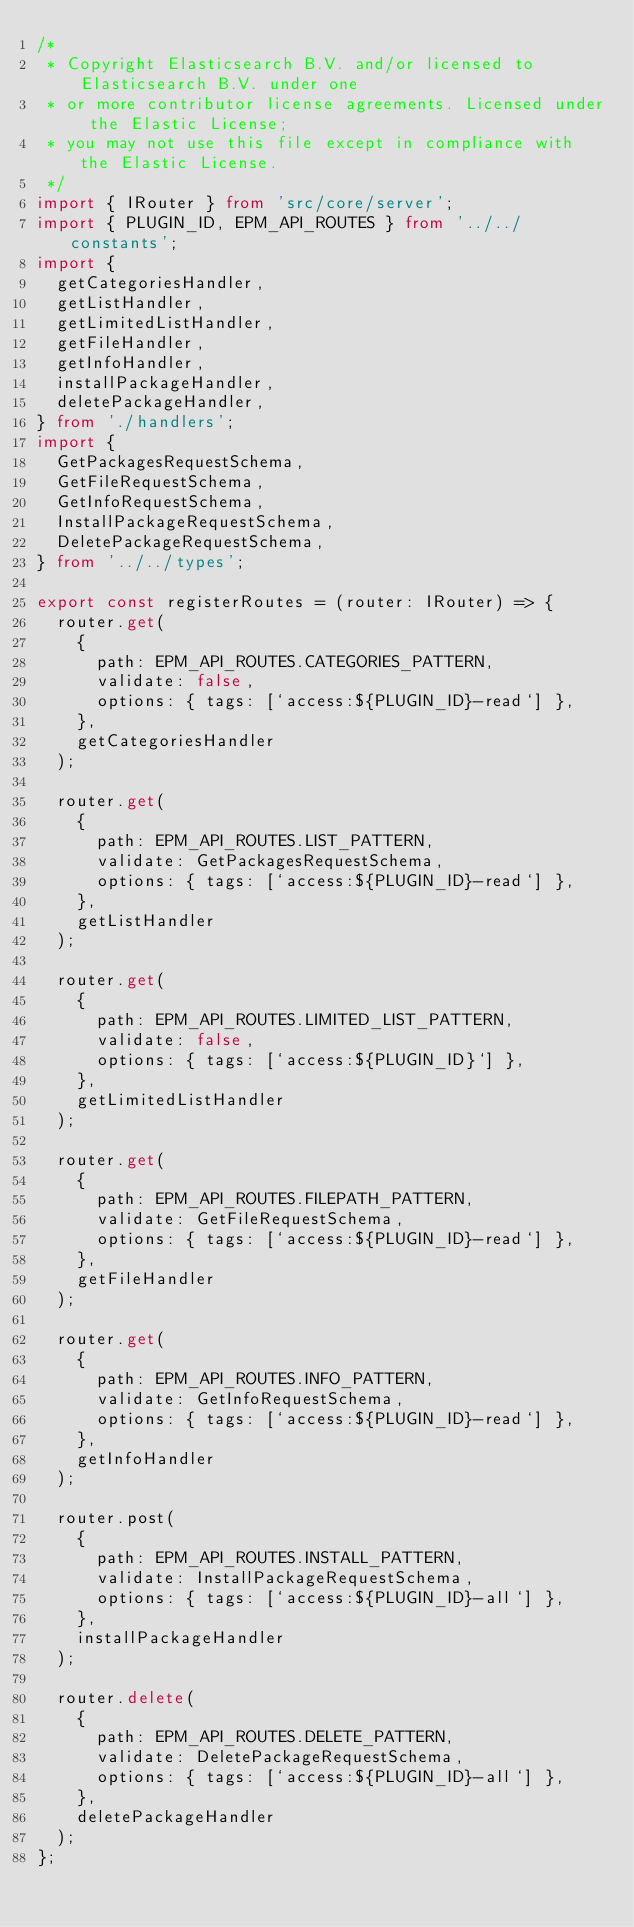Convert code to text. <code><loc_0><loc_0><loc_500><loc_500><_TypeScript_>/*
 * Copyright Elasticsearch B.V. and/or licensed to Elasticsearch B.V. under one
 * or more contributor license agreements. Licensed under the Elastic License;
 * you may not use this file except in compliance with the Elastic License.
 */
import { IRouter } from 'src/core/server';
import { PLUGIN_ID, EPM_API_ROUTES } from '../../constants';
import {
  getCategoriesHandler,
  getListHandler,
  getLimitedListHandler,
  getFileHandler,
  getInfoHandler,
  installPackageHandler,
  deletePackageHandler,
} from './handlers';
import {
  GetPackagesRequestSchema,
  GetFileRequestSchema,
  GetInfoRequestSchema,
  InstallPackageRequestSchema,
  DeletePackageRequestSchema,
} from '../../types';

export const registerRoutes = (router: IRouter) => {
  router.get(
    {
      path: EPM_API_ROUTES.CATEGORIES_PATTERN,
      validate: false,
      options: { tags: [`access:${PLUGIN_ID}-read`] },
    },
    getCategoriesHandler
  );

  router.get(
    {
      path: EPM_API_ROUTES.LIST_PATTERN,
      validate: GetPackagesRequestSchema,
      options: { tags: [`access:${PLUGIN_ID}-read`] },
    },
    getListHandler
  );

  router.get(
    {
      path: EPM_API_ROUTES.LIMITED_LIST_PATTERN,
      validate: false,
      options: { tags: [`access:${PLUGIN_ID}`] },
    },
    getLimitedListHandler
  );

  router.get(
    {
      path: EPM_API_ROUTES.FILEPATH_PATTERN,
      validate: GetFileRequestSchema,
      options: { tags: [`access:${PLUGIN_ID}-read`] },
    },
    getFileHandler
  );

  router.get(
    {
      path: EPM_API_ROUTES.INFO_PATTERN,
      validate: GetInfoRequestSchema,
      options: { tags: [`access:${PLUGIN_ID}-read`] },
    },
    getInfoHandler
  );

  router.post(
    {
      path: EPM_API_ROUTES.INSTALL_PATTERN,
      validate: InstallPackageRequestSchema,
      options: { tags: [`access:${PLUGIN_ID}-all`] },
    },
    installPackageHandler
  );

  router.delete(
    {
      path: EPM_API_ROUTES.DELETE_PATTERN,
      validate: DeletePackageRequestSchema,
      options: { tags: [`access:${PLUGIN_ID}-all`] },
    },
    deletePackageHandler
  );
};
</code> 